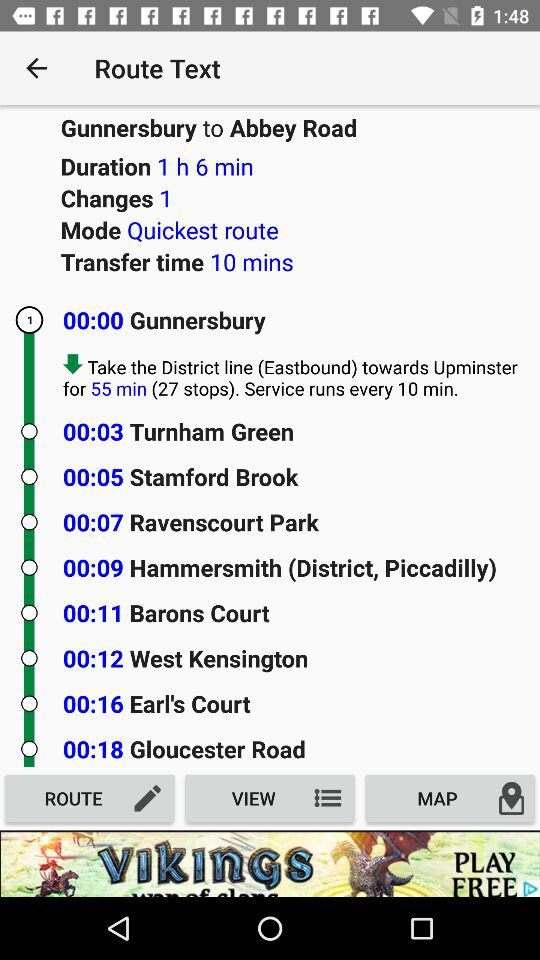What is the transfer time? The transfer time is 10 minutes. 